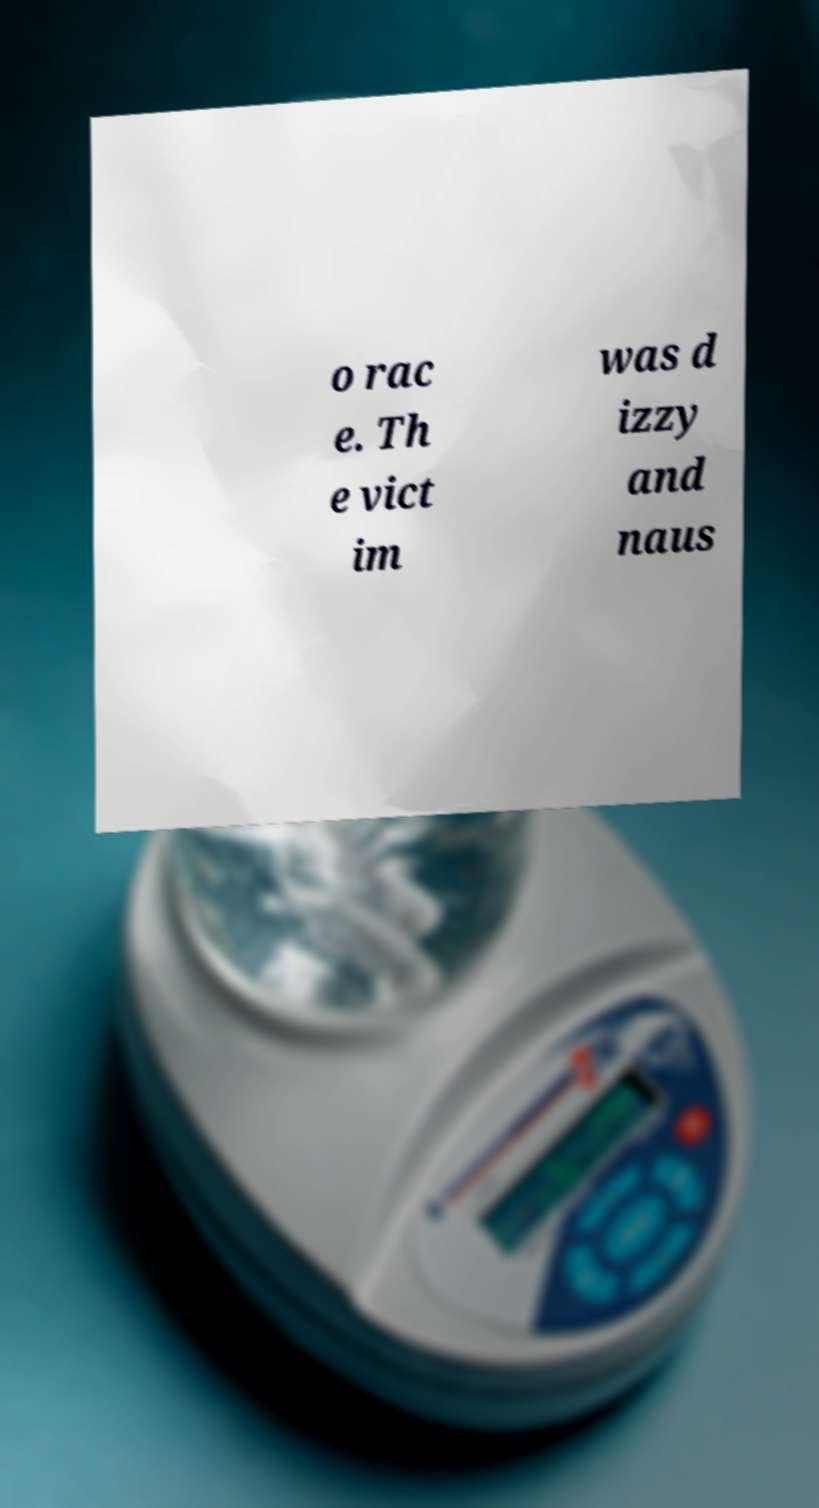Can you read and provide the text displayed in the image?This photo seems to have some interesting text. Can you extract and type it out for me? o rac e. Th e vict im was d izzy and naus 